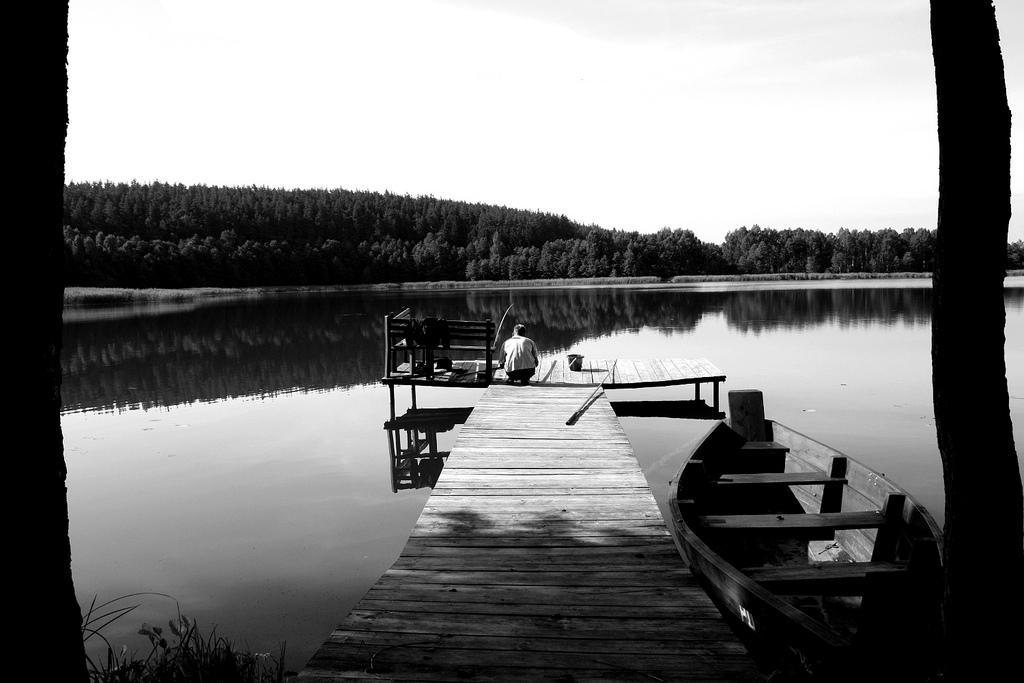Can you describe this image briefly? In this black and white image, we can see a person on dock. There is a boat floating on the water. There are some trees in the middle of the image. There is a sky at the top of the image. There is a stem on the left and on the right side of the image. 